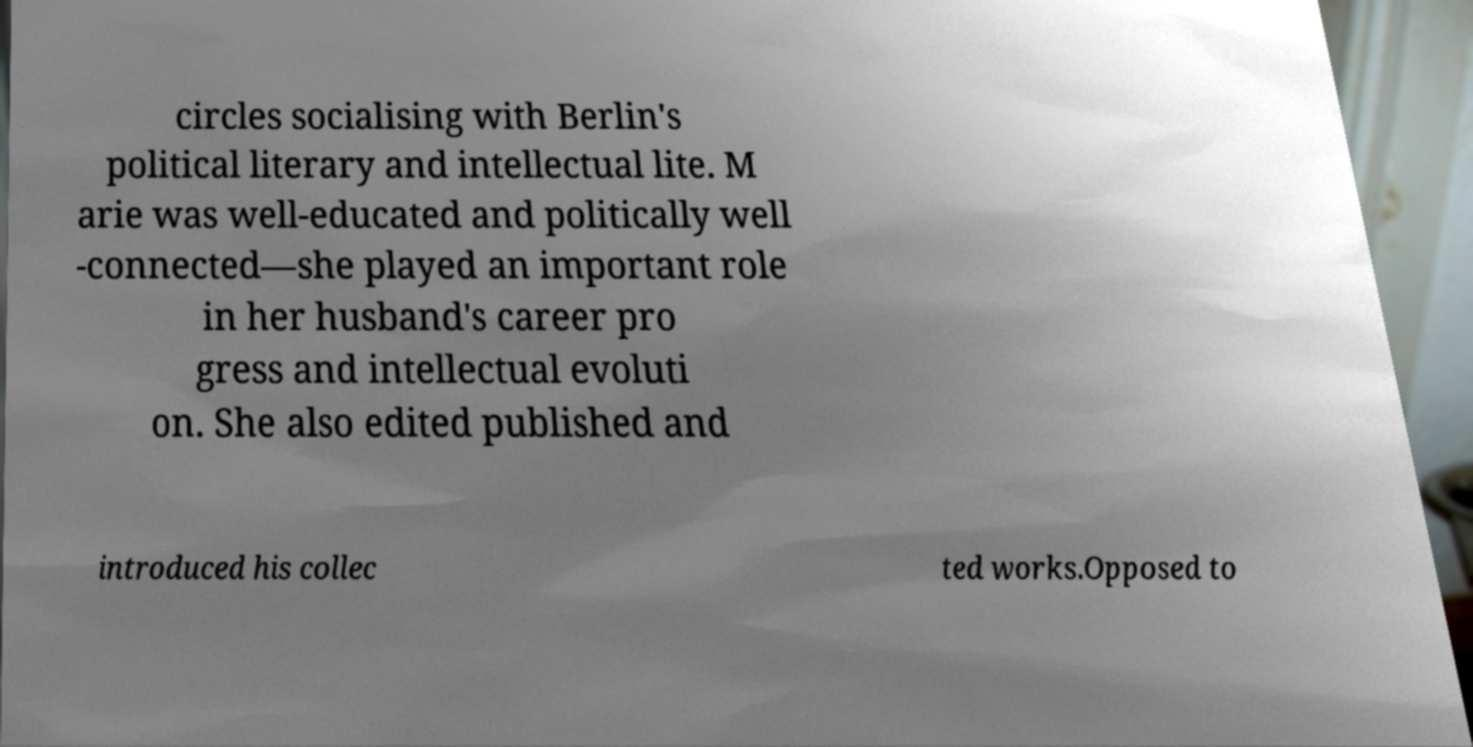Could you extract and type out the text from this image? circles socialising with Berlin's political literary and intellectual lite. M arie was well-educated and politically well -connected—she played an important role in her husband's career pro gress and intellectual evoluti on. She also edited published and introduced his collec ted works.Opposed to 